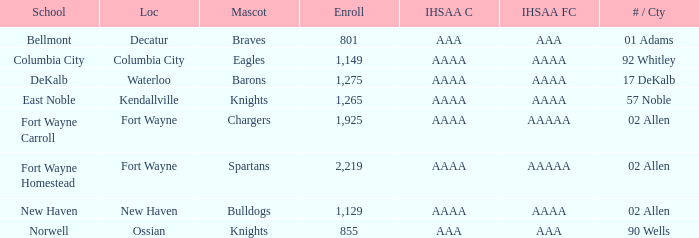What school has a mascot of the spartans with an AAAA IHSAA class and more than 1,275 enrolled? Fort Wayne Homestead. 